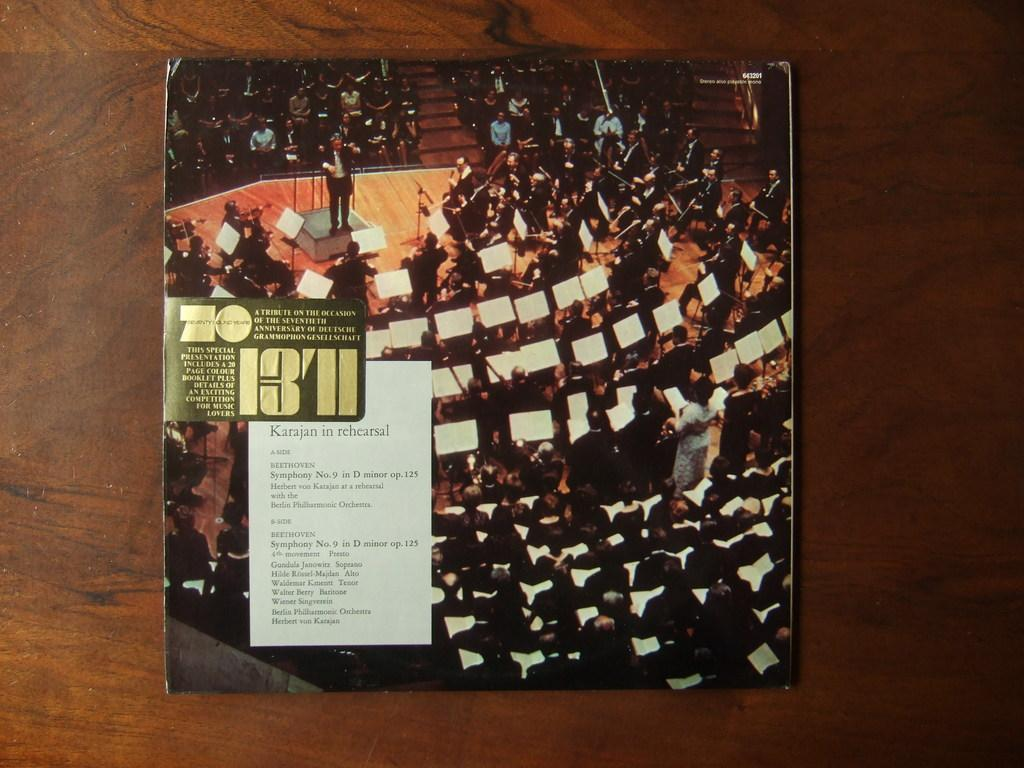<image>
Render a clear and concise summary of the photo. A symphony tribute on the occasion of the seventieth anniversary for a celebration. 